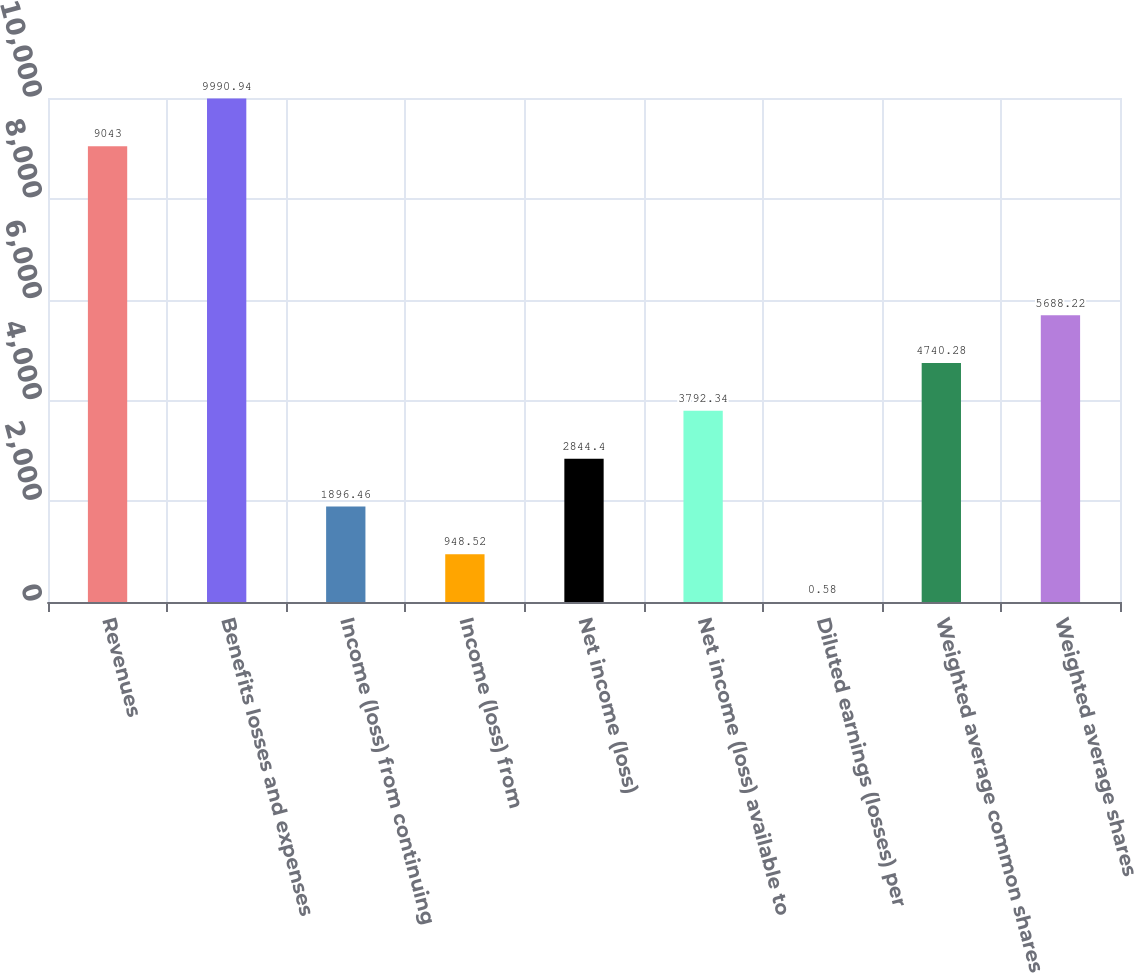Convert chart. <chart><loc_0><loc_0><loc_500><loc_500><bar_chart><fcel>Revenues<fcel>Benefits losses and expenses<fcel>Income (loss) from continuing<fcel>Income (loss) from<fcel>Net income (loss)<fcel>Net income (loss) available to<fcel>Diluted earnings (losses) per<fcel>Weighted average common shares<fcel>Weighted average shares<nl><fcel>9043<fcel>9990.94<fcel>1896.46<fcel>948.52<fcel>2844.4<fcel>3792.34<fcel>0.58<fcel>4740.28<fcel>5688.22<nl></chart> 